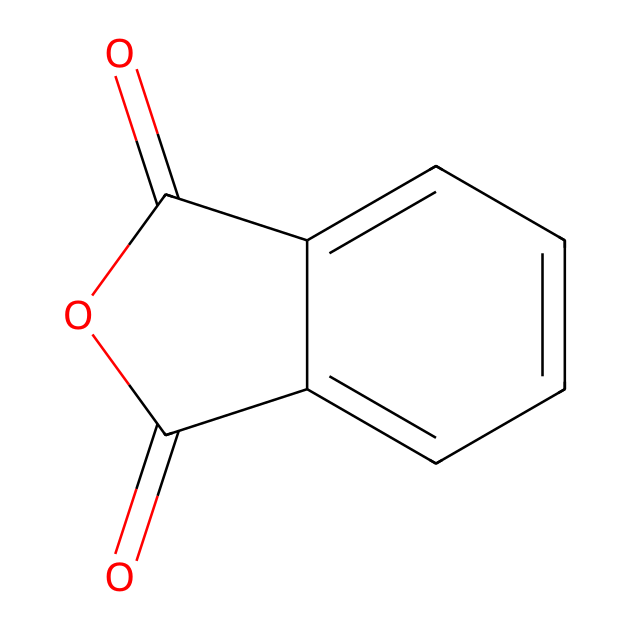What is the molecular formula of phthalic anhydride? The SMILES notation can be analyzed to determine the elements present. The structure contains two carbonyl (C=O) groups, and observing the aromatic ring indicates carbon and hydrogen atoms. In total, there are 8 carbons, 4 oxygens, and 4 hydrogens which gives the molecular formula as C8H4O3.
Answer: C8H4O3 How many carbon atoms are in phthalic anhydride? Counting the carbon atoms in the SMILES representation shows that there are 8 carbon atoms (from both the aromatic ring and the carbonyl groups).
Answer: 8 How many rings are present in the structure of phthalic anhydride? The SMILES shows there is one aromatic ring that is part of the cyclic structure of the anhydride. Additionally, it indicates another fused ring formation with the carbonyl groups. Thus, there is one ring in total.
Answer: 1 What is the functional group present in phthalic anhydride? Analyzing the structure shows two carbonyl groups are present in the anhydride form (–C(=O)–). The combination of these functional groups characterizes it as an anhydride.
Answer: anhydride What chemical properties would you expect from phthalic anhydride based on its structure? The presence of carbonyl groups indicates potential for reactivity and making it a electrophilic compound. The aromatic character contributes to stability but could also suggest behavior in substitutions. Thus, one might expect reactivity and stability.
Answer: reactive and stable Why might phthalic anhydride be relevant at a crime scene? Phthalic anhydride is commonly used in various dye production and synthetic processes. Its presence at a crime scene may indicate the use of dyes or chemical processes related to the crime, showcasing its industrial significance.
Answer: dye production 